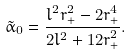Convert formula to latex. <formula><loc_0><loc_0><loc_500><loc_500>\tilde { \alpha } _ { 0 } = \frac { l ^ { 2 } r _ { + } ^ { 2 } - 2 r _ { + } ^ { 4 } } { 2 l ^ { 2 } + 1 2 r _ { + } ^ { 2 } } .</formula> 